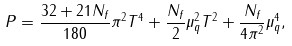Convert formula to latex. <formula><loc_0><loc_0><loc_500><loc_500>P = \frac { 3 2 + 2 1 N _ { f } } { 1 8 0 } \pi ^ { 2 } T ^ { 4 } + \frac { N _ { f } } { 2 } \mu _ { q } ^ { 2 } T ^ { 2 } + \frac { N _ { f } } { 4 \pi ^ { 2 } } \mu _ { q } ^ { 4 } ,</formula> 